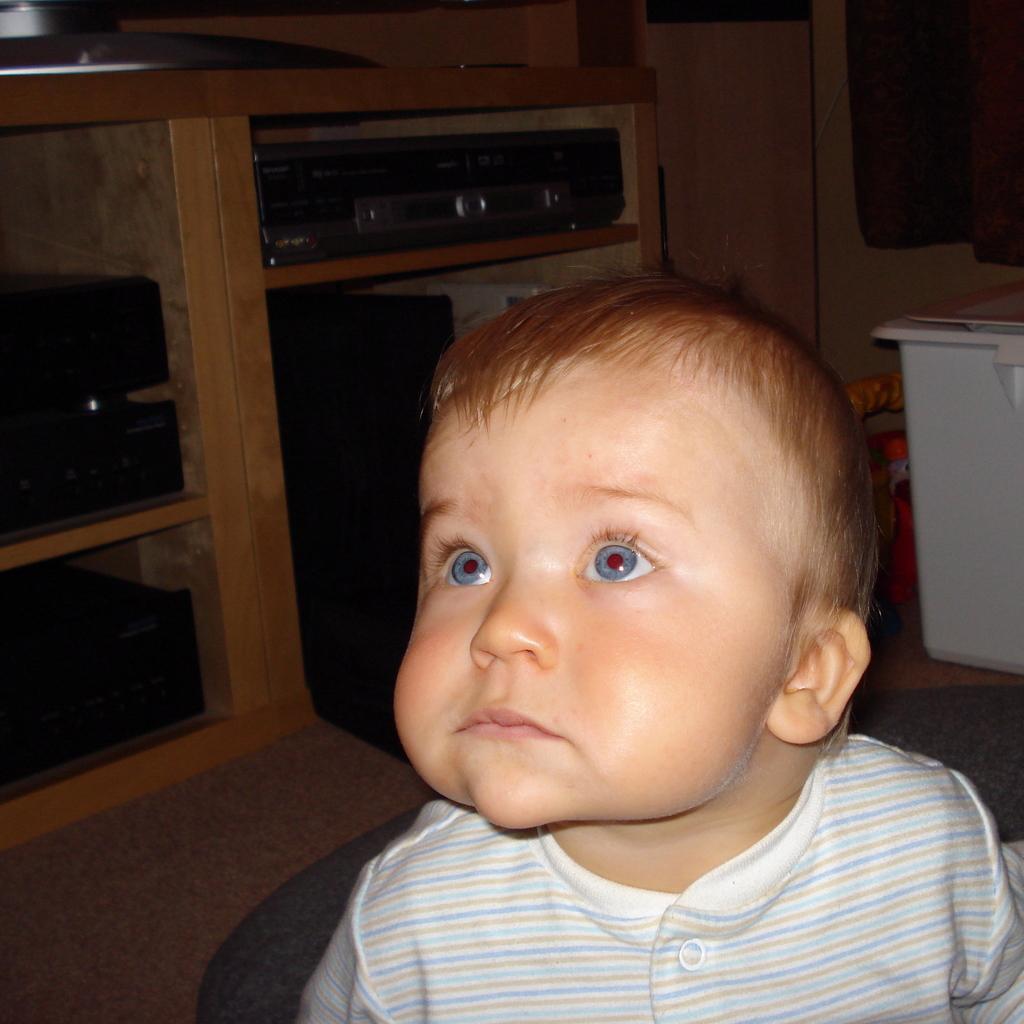Could you give a brief overview of what you see in this image? There is a small baby in the foreground area of the image, there is a rack and other objects in the background. 